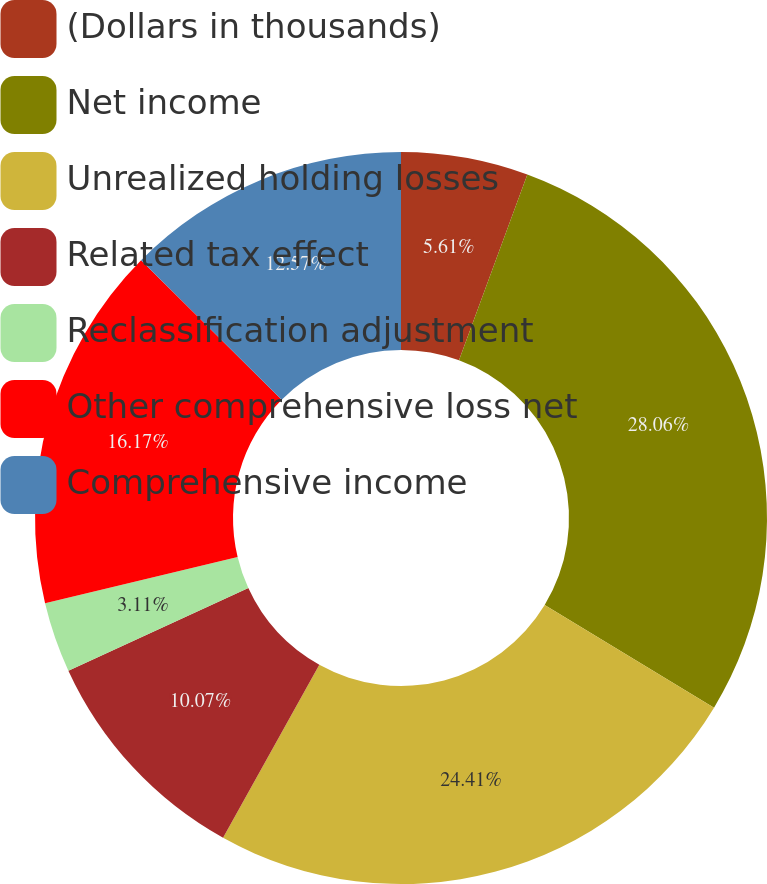Convert chart. <chart><loc_0><loc_0><loc_500><loc_500><pie_chart><fcel>(Dollars in thousands)<fcel>Net income<fcel>Unrealized holding losses<fcel>Related tax effect<fcel>Reclassification adjustment<fcel>Other comprehensive loss net<fcel>Comprehensive income<nl><fcel>5.61%<fcel>28.06%<fcel>24.41%<fcel>10.07%<fcel>3.11%<fcel>16.17%<fcel>12.57%<nl></chart> 